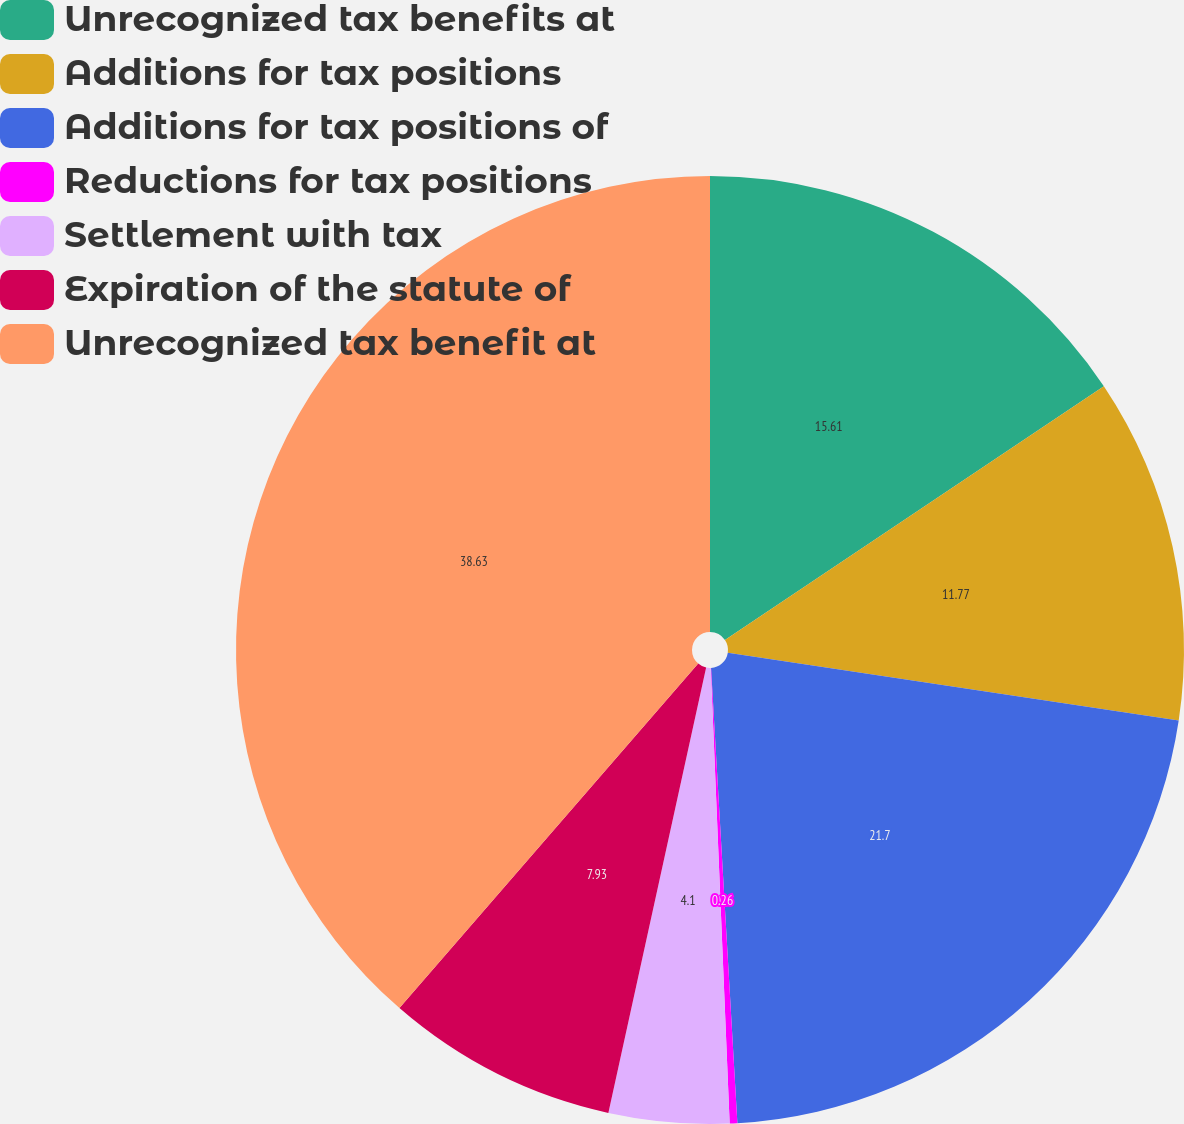Convert chart to OTSL. <chart><loc_0><loc_0><loc_500><loc_500><pie_chart><fcel>Unrecognized tax benefits at<fcel>Additions for tax positions<fcel>Additions for tax positions of<fcel>Reductions for tax positions<fcel>Settlement with tax<fcel>Expiration of the statute of<fcel>Unrecognized tax benefit at<nl><fcel>15.61%<fcel>11.77%<fcel>21.7%<fcel>0.26%<fcel>4.1%<fcel>7.93%<fcel>38.63%<nl></chart> 